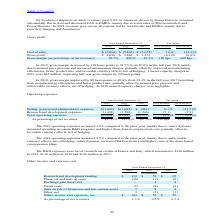According to Stmicroelectronics's financial document, In 2019, what were the reasons for increase in operating expenses? due to salary dynamic, increased spending in certain R&D programs and higher share-based compensation cost, partially offset by favorable currency effects, net of hedging.. The document states: "increased 3.9% compared to the prior year, mainly due to salary dynamic, increased spending in certain R&D programs and higher share-based compensatio..." Also, In 2018, what were the reasons for increase in operating expenses? due to unfavorable currency effects, net of hedging, salary dynamic, increased R&D activities and higher costs of the share-based compensation plans.. The document states: "increased 9.5% compared to the prior year, mainly due to unfavorable currency effects, net of hedging, salary dynamic, increased R&D activities and hi..." Also, How much did the R&D expenses amounted for in 2019, 2018 and 2017? The R&D expenses were net of research tax credits in France and Italy, which amounted to $126 million in 2019, $138 million in 2018 and $124 million in 2017.. The document states: "The R&D expenses were net of research tax credits in France and Italy, which amounted to $126 million in 2019, $138 million in 2018 and $124 million i..." Also, can you calculate: What is the average Selling, general and administrative expenses? To answer this question, I need to perform calculations using the financial data. The calculation is: (1,093+1,095+981) / 3, which equals 1056.33 (in millions). This is based on the information: "Selling, general and administrative expenses $(1,093) $(1,095) $ (981) 0.3% (11.7)% g, general and administrative expenses $(1,093) $(1,095) $ (981) 0.3% (11.7)% and administrative expenses $(1,093) $..." The key data points involved are: 1,093, 1,095, 981. Also, can you calculate: What is the average Research and development expenses? To answer this question, I need to perform calculations using the financial data. The calculation is: (1,498+1,398+1,296) / 3, which equals 1397.33 (in millions). This is based on the information: "esearch and development expenses (1,498) (1,398) (1,296) (7.1) (7.9) Research and development expenses (1,498) (1,398) (1,296) (7.1) (7.9) Research and development expenses (1,498) (1,398) (1,296) (7...." The key data points involved are: 1,296, 1,398, 1,498. Also, can you calculate: What is the increase/ (decrease) in total operating expenses as percentage of net revenues from 2017 to 2019? Based on the calculation: 27.1-27.3, the result is -0.2 (percentage). This is based on the information: "As percentage of net revenues (27.1)% (25.8)% (27.3)% -130 bps +150 bps As percentage of net revenues (27.1)% (25.8)% (27.3)% -130 bps +150 bps..." The key data points involved are: 27.1, 27.3. 